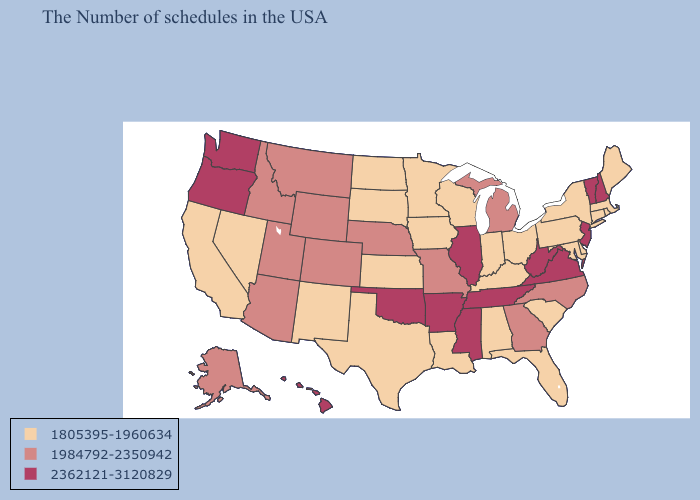Does the first symbol in the legend represent the smallest category?
Answer briefly. Yes. Among the states that border Tennessee , does Georgia have the highest value?
Short answer required. No. Name the states that have a value in the range 1805395-1960634?
Give a very brief answer. Maine, Massachusetts, Rhode Island, Connecticut, New York, Delaware, Maryland, Pennsylvania, South Carolina, Ohio, Florida, Kentucky, Indiana, Alabama, Wisconsin, Louisiana, Minnesota, Iowa, Kansas, Texas, South Dakota, North Dakota, New Mexico, Nevada, California. Does Delaware have the lowest value in the USA?
Answer briefly. Yes. What is the highest value in the USA?
Short answer required. 2362121-3120829. Among the states that border Kentucky , does Indiana have the lowest value?
Short answer required. Yes. Which states have the lowest value in the USA?
Answer briefly. Maine, Massachusetts, Rhode Island, Connecticut, New York, Delaware, Maryland, Pennsylvania, South Carolina, Ohio, Florida, Kentucky, Indiana, Alabama, Wisconsin, Louisiana, Minnesota, Iowa, Kansas, Texas, South Dakota, North Dakota, New Mexico, Nevada, California. What is the value of New Jersey?
Be succinct. 2362121-3120829. Among the states that border Alabama , which have the highest value?
Write a very short answer. Tennessee, Mississippi. What is the lowest value in states that border New Mexico?
Write a very short answer. 1805395-1960634. Does New Mexico have the same value as Massachusetts?
Short answer required. Yes. Name the states that have a value in the range 1984792-2350942?
Give a very brief answer. North Carolina, Georgia, Michigan, Missouri, Nebraska, Wyoming, Colorado, Utah, Montana, Arizona, Idaho, Alaska. Among the states that border North Dakota , which have the lowest value?
Short answer required. Minnesota, South Dakota. Does the map have missing data?
Give a very brief answer. No. What is the value of New Mexico?
Concise answer only. 1805395-1960634. 